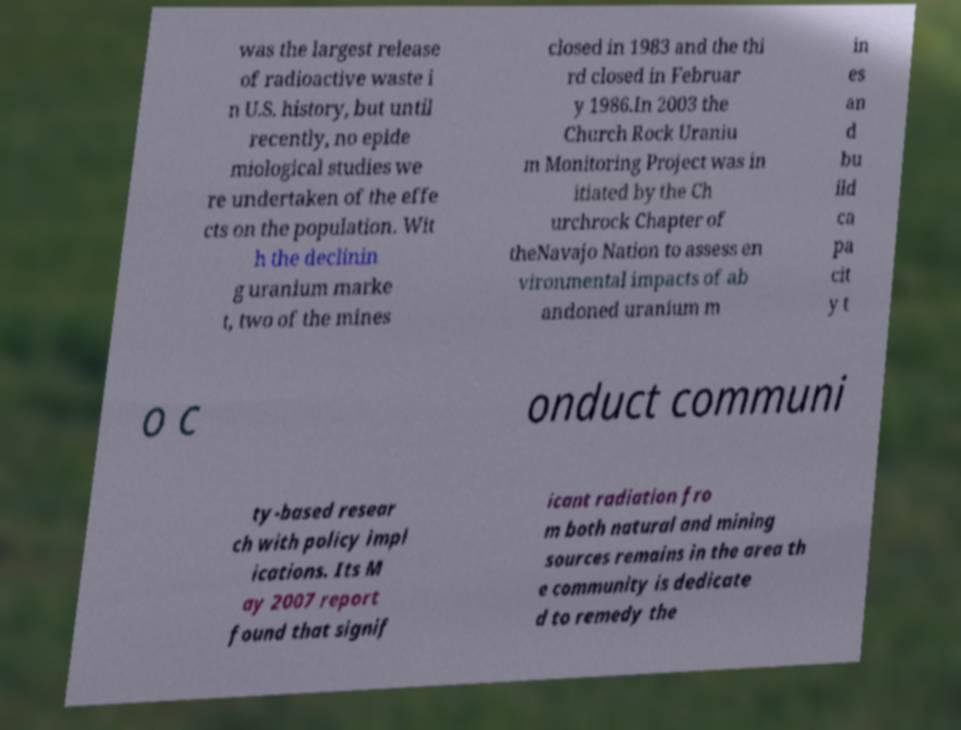Please identify and transcribe the text found in this image. was the largest release of radioactive waste i n U.S. history, but until recently, no epide miological studies we re undertaken of the effe cts on the population. Wit h the declinin g uranium marke t, two of the mines closed in 1983 and the thi rd closed in Februar y 1986.In 2003 the Church Rock Uraniu m Monitoring Project was in itiated by the Ch urchrock Chapter of theNavajo Nation to assess en vironmental impacts of ab andoned uranium m in es an d bu ild ca pa cit y t o c onduct communi ty-based resear ch with policy impl ications. Its M ay 2007 report found that signif icant radiation fro m both natural and mining sources remains in the area th e community is dedicate d to remedy the 